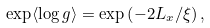Convert formula to latex. <formula><loc_0><loc_0><loc_500><loc_500>\exp \langle \log g \rangle = \exp \left ( - 2 L _ { x } / \xi \right ) ,</formula> 